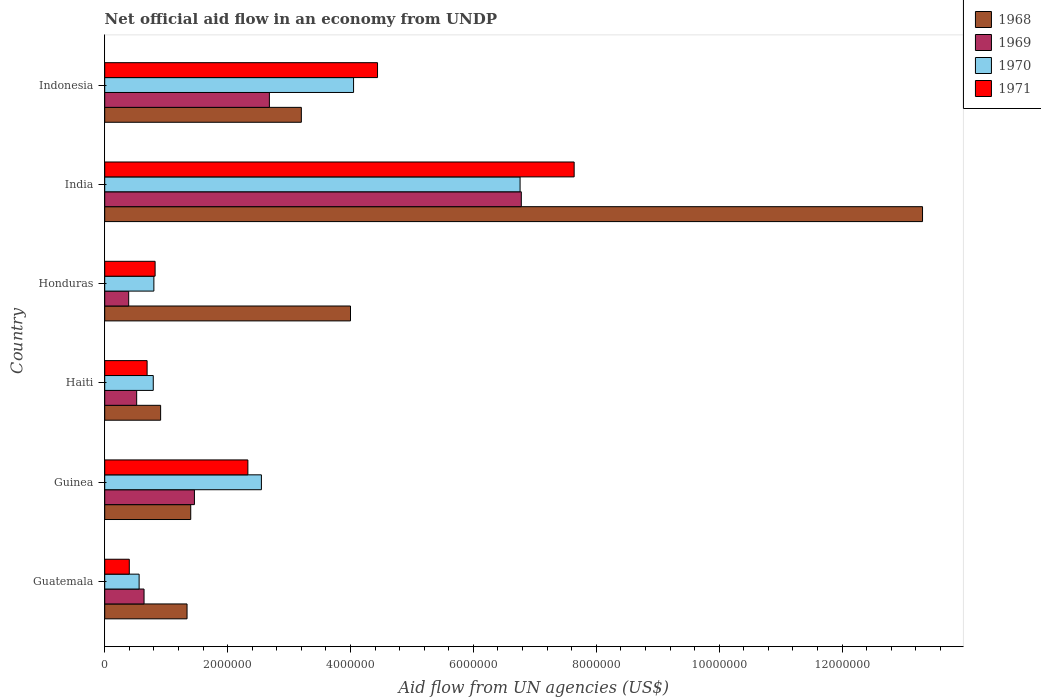Are the number of bars per tick equal to the number of legend labels?
Keep it short and to the point. Yes. Are the number of bars on each tick of the Y-axis equal?
Offer a terse response. Yes. What is the label of the 3rd group of bars from the top?
Offer a terse response. Honduras. What is the net official aid flow in 1968 in Guatemala?
Ensure brevity in your answer.  1.34e+06. Across all countries, what is the maximum net official aid flow in 1968?
Make the answer very short. 1.33e+07. Across all countries, what is the minimum net official aid flow in 1971?
Make the answer very short. 4.00e+05. In which country was the net official aid flow in 1968 maximum?
Provide a short and direct response. India. In which country was the net official aid flow in 1968 minimum?
Offer a terse response. Haiti. What is the total net official aid flow in 1971 in the graph?
Ensure brevity in your answer.  1.63e+07. What is the difference between the net official aid flow in 1969 in Haiti and the net official aid flow in 1970 in Indonesia?
Give a very brief answer. -3.53e+06. What is the average net official aid flow in 1969 per country?
Provide a succinct answer. 2.08e+06. What is the difference between the net official aid flow in 1968 and net official aid flow in 1969 in Guinea?
Offer a very short reply. -6.00e+04. What is the ratio of the net official aid flow in 1968 in Guinea to that in India?
Give a very brief answer. 0.11. What is the difference between the highest and the second highest net official aid flow in 1968?
Provide a succinct answer. 9.31e+06. What is the difference between the highest and the lowest net official aid flow in 1971?
Your answer should be very brief. 7.24e+06. In how many countries, is the net official aid flow in 1970 greater than the average net official aid flow in 1970 taken over all countries?
Your response must be concise. 2. Is the sum of the net official aid flow in 1970 in Guinea and India greater than the maximum net official aid flow in 1968 across all countries?
Give a very brief answer. No. What does the 4th bar from the top in India represents?
Ensure brevity in your answer.  1968. What does the 2nd bar from the bottom in India represents?
Give a very brief answer. 1969. How many bars are there?
Make the answer very short. 24. Are all the bars in the graph horizontal?
Make the answer very short. Yes. How many legend labels are there?
Keep it short and to the point. 4. What is the title of the graph?
Your answer should be very brief. Net official aid flow in an economy from UNDP. What is the label or title of the X-axis?
Offer a terse response. Aid flow from UN agencies (US$). What is the Aid flow from UN agencies (US$) in 1968 in Guatemala?
Your answer should be compact. 1.34e+06. What is the Aid flow from UN agencies (US$) in 1969 in Guatemala?
Ensure brevity in your answer.  6.40e+05. What is the Aid flow from UN agencies (US$) of 1970 in Guatemala?
Provide a short and direct response. 5.60e+05. What is the Aid flow from UN agencies (US$) of 1968 in Guinea?
Provide a short and direct response. 1.40e+06. What is the Aid flow from UN agencies (US$) of 1969 in Guinea?
Offer a terse response. 1.46e+06. What is the Aid flow from UN agencies (US$) of 1970 in Guinea?
Your answer should be compact. 2.55e+06. What is the Aid flow from UN agencies (US$) in 1971 in Guinea?
Provide a succinct answer. 2.33e+06. What is the Aid flow from UN agencies (US$) of 1968 in Haiti?
Provide a succinct answer. 9.10e+05. What is the Aid flow from UN agencies (US$) in 1969 in Haiti?
Your answer should be very brief. 5.20e+05. What is the Aid flow from UN agencies (US$) in 1970 in Haiti?
Keep it short and to the point. 7.90e+05. What is the Aid flow from UN agencies (US$) of 1971 in Haiti?
Ensure brevity in your answer.  6.90e+05. What is the Aid flow from UN agencies (US$) in 1970 in Honduras?
Provide a succinct answer. 8.00e+05. What is the Aid flow from UN agencies (US$) in 1971 in Honduras?
Provide a short and direct response. 8.20e+05. What is the Aid flow from UN agencies (US$) of 1968 in India?
Your response must be concise. 1.33e+07. What is the Aid flow from UN agencies (US$) in 1969 in India?
Provide a short and direct response. 6.78e+06. What is the Aid flow from UN agencies (US$) in 1970 in India?
Give a very brief answer. 6.76e+06. What is the Aid flow from UN agencies (US$) in 1971 in India?
Your answer should be compact. 7.64e+06. What is the Aid flow from UN agencies (US$) of 1968 in Indonesia?
Give a very brief answer. 3.20e+06. What is the Aid flow from UN agencies (US$) in 1969 in Indonesia?
Your answer should be very brief. 2.68e+06. What is the Aid flow from UN agencies (US$) of 1970 in Indonesia?
Your answer should be compact. 4.05e+06. What is the Aid flow from UN agencies (US$) of 1971 in Indonesia?
Your answer should be very brief. 4.44e+06. Across all countries, what is the maximum Aid flow from UN agencies (US$) in 1968?
Provide a short and direct response. 1.33e+07. Across all countries, what is the maximum Aid flow from UN agencies (US$) of 1969?
Provide a short and direct response. 6.78e+06. Across all countries, what is the maximum Aid flow from UN agencies (US$) in 1970?
Ensure brevity in your answer.  6.76e+06. Across all countries, what is the maximum Aid flow from UN agencies (US$) in 1971?
Provide a short and direct response. 7.64e+06. Across all countries, what is the minimum Aid flow from UN agencies (US$) in 1968?
Ensure brevity in your answer.  9.10e+05. Across all countries, what is the minimum Aid flow from UN agencies (US$) of 1970?
Offer a very short reply. 5.60e+05. Across all countries, what is the minimum Aid flow from UN agencies (US$) of 1971?
Ensure brevity in your answer.  4.00e+05. What is the total Aid flow from UN agencies (US$) of 1968 in the graph?
Offer a very short reply. 2.42e+07. What is the total Aid flow from UN agencies (US$) in 1969 in the graph?
Your response must be concise. 1.25e+07. What is the total Aid flow from UN agencies (US$) of 1970 in the graph?
Provide a succinct answer. 1.55e+07. What is the total Aid flow from UN agencies (US$) of 1971 in the graph?
Provide a short and direct response. 1.63e+07. What is the difference between the Aid flow from UN agencies (US$) in 1968 in Guatemala and that in Guinea?
Your response must be concise. -6.00e+04. What is the difference between the Aid flow from UN agencies (US$) in 1969 in Guatemala and that in Guinea?
Offer a very short reply. -8.20e+05. What is the difference between the Aid flow from UN agencies (US$) of 1970 in Guatemala and that in Guinea?
Your answer should be very brief. -1.99e+06. What is the difference between the Aid flow from UN agencies (US$) of 1971 in Guatemala and that in Guinea?
Provide a succinct answer. -1.93e+06. What is the difference between the Aid flow from UN agencies (US$) in 1968 in Guatemala and that in Haiti?
Provide a succinct answer. 4.30e+05. What is the difference between the Aid flow from UN agencies (US$) in 1969 in Guatemala and that in Haiti?
Ensure brevity in your answer.  1.20e+05. What is the difference between the Aid flow from UN agencies (US$) of 1968 in Guatemala and that in Honduras?
Ensure brevity in your answer.  -2.66e+06. What is the difference between the Aid flow from UN agencies (US$) of 1969 in Guatemala and that in Honduras?
Ensure brevity in your answer.  2.50e+05. What is the difference between the Aid flow from UN agencies (US$) in 1970 in Guatemala and that in Honduras?
Your answer should be very brief. -2.40e+05. What is the difference between the Aid flow from UN agencies (US$) of 1971 in Guatemala and that in Honduras?
Keep it short and to the point. -4.20e+05. What is the difference between the Aid flow from UN agencies (US$) in 1968 in Guatemala and that in India?
Your response must be concise. -1.20e+07. What is the difference between the Aid flow from UN agencies (US$) in 1969 in Guatemala and that in India?
Offer a terse response. -6.14e+06. What is the difference between the Aid flow from UN agencies (US$) of 1970 in Guatemala and that in India?
Keep it short and to the point. -6.20e+06. What is the difference between the Aid flow from UN agencies (US$) in 1971 in Guatemala and that in India?
Ensure brevity in your answer.  -7.24e+06. What is the difference between the Aid flow from UN agencies (US$) of 1968 in Guatemala and that in Indonesia?
Ensure brevity in your answer.  -1.86e+06. What is the difference between the Aid flow from UN agencies (US$) in 1969 in Guatemala and that in Indonesia?
Your answer should be compact. -2.04e+06. What is the difference between the Aid flow from UN agencies (US$) of 1970 in Guatemala and that in Indonesia?
Your response must be concise. -3.49e+06. What is the difference between the Aid flow from UN agencies (US$) in 1971 in Guatemala and that in Indonesia?
Keep it short and to the point. -4.04e+06. What is the difference between the Aid flow from UN agencies (US$) of 1968 in Guinea and that in Haiti?
Provide a short and direct response. 4.90e+05. What is the difference between the Aid flow from UN agencies (US$) in 1969 in Guinea and that in Haiti?
Give a very brief answer. 9.40e+05. What is the difference between the Aid flow from UN agencies (US$) in 1970 in Guinea and that in Haiti?
Offer a terse response. 1.76e+06. What is the difference between the Aid flow from UN agencies (US$) in 1971 in Guinea and that in Haiti?
Your response must be concise. 1.64e+06. What is the difference between the Aid flow from UN agencies (US$) of 1968 in Guinea and that in Honduras?
Your response must be concise. -2.60e+06. What is the difference between the Aid flow from UN agencies (US$) in 1969 in Guinea and that in Honduras?
Offer a terse response. 1.07e+06. What is the difference between the Aid flow from UN agencies (US$) in 1970 in Guinea and that in Honduras?
Your answer should be very brief. 1.75e+06. What is the difference between the Aid flow from UN agencies (US$) in 1971 in Guinea and that in Honduras?
Keep it short and to the point. 1.51e+06. What is the difference between the Aid flow from UN agencies (US$) in 1968 in Guinea and that in India?
Offer a very short reply. -1.19e+07. What is the difference between the Aid flow from UN agencies (US$) of 1969 in Guinea and that in India?
Offer a very short reply. -5.32e+06. What is the difference between the Aid flow from UN agencies (US$) in 1970 in Guinea and that in India?
Offer a very short reply. -4.21e+06. What is the difference between the Aid flow from UN agencies (US$) in 1971 in Guinea and that in India?
Provide a short and direct response. -5.31e+06. What is the difference between the Aid flow from UN agencies (US$) of 1968 in Guinea and that in Indonesia?
Offer a very short reply. -1.80e+06. What is the difference between the Aid flow from UN agencies (US$) in 1969 in Guinea and that in Indonesia?
Offer a terse response. -1.22e+06. What is the difference between the Aid flow from UN agencies (US$) of 1970 in Guinea and that in Indonesia?
Your answer should be very brief. -1.50e+06. What is the difference between the Aid flow from UN agencies (US$) of 1971 in Guinea and that in Indonesia?
Provide a succinct answer. -2.11e+06. What is the difference between the Aid flow from UN agencies (US$) in 1968 in Haiti and that in Honduras?
Ensure brevity in your answer.  -3.09e+06. What is the difference between the Aid flow from UN agencies (US$) of 1968 in Haiti and that in India?
Provide a short and direct response. -1.24e+07. What is the difference between the Aid flow from UN agencies (US$) in 1969 in Haiti and that in India?
Provide a short and direct response. -6.26e+06. What is the difference between the Aid flow from UN agencies (US$) of 1970 in Haiti and that in India?
Make the answer very short. -5.97e+06. What is the difference between the Aid flow from UN agencies (US$) in 1971 in Haiti and that in India?
Offer a very short reply. -6.95e+06. What is the difference between the Aid flow from UN agencies (US$) in 1968 in Haiti and that in Indonesia?
Provide a short and direct response. -2.29e+06. What is the difference between the Aid flow from UN agencies (US$) in 1969 in Haiti and that in Indonesia?
Offer a terse response. -2.16e+06. What is the difference between the Aid flow from UN agencies (US$) of 1970 in Haiti and that in Indonesia?
Keep it short and to the point. -3.26e+06. What is the difference between the Aid flow from UN agencies (US$) of 1971 in Haiti and that in Indonesia?
Offer a very short reply. -3.75e+06. What is the difference between the Aid flow from UN agencies (US$) of 1968 in Honduras and that in India?
Provide a short and direct response. -9.31e+06. What is the difference between the Aid flow from UN agencies (US$) of 1969 in Honduras and that in India?
Your answer should be compact. -6.39e+06. What is the difference between the Aid flow from UN agencies (US$) in 1970 in Honduras and that in India?
Offer a terse response. -5.96e+06. What is the difference between the Aid flow from UN agencies (US$) in 1971 in Honduras and that in India?
Keep it short and to the point. -6.82e+06. What is the difference between the Aid flow from UN agencies (US$) of 1969 in Honduras and that in Indonesia?
Provide a succinct answer. -2.29e+06. What is the difference between the Aid flow from UN agencies (US$) of 1970 in Honduras and that in Indonesia?
Ensure brevity in your answer.  -3.25e+06. What is the difference between the Aid flow from UN agencies (US$) in 1971 in Honduras and that in Indonesia?
Give a very brief answer. -3.62e+06. What is the difference between the Aid flow from UN agencies (US$) of 1968 in India and that in Indonesia?
Make the answer very short. 1.01e+07. What is the difference between the Aid flow from UN agencies (US$) in 1969 in India and that in Indonesia?
Give a very brief answer. 4.10e+06. What is the difference between the Aid flow from UN agencies (US$) of 1970 in India and that in Indonesia?
Offer a terse response. 2.71e+06. What is the difference between the Aid flow from UN agencies (US$) in 1971 in India and that in Indonesia?
Provide a short and direct response. 3.20e+06. What is the difference between the Aid flow from UN agencies (US$) in 1968 in Guatemala and the Aid flow from UN agencies (US$) in 1969 in Guinea?
Keep it short and to the point. -1.20e+05. What is the difference between the Aid flow from UN agencies (US$) in 1968 in Guatemala and the Aid flow from UN agencies (US$) in 1970 in Guinea?
Make the answer very short. -1.21e+06. What is the difference between the Aid flow from UN agencies (US$) in 1968 in Guatemala and the Aid flow from UN agencies (US$) in 1971 in Guinea?
Offer a very short reply. -9.90e+05. What is the difference between the Aid flow from UN agencies (US$) of 1969 in Guatemala and the Aid flow from UN agencies (US$) of 1970 in Guinea?
Your answer should be very brief. -1.91e+06. What is the difference between the Aid flow from UN agencies (US$) in 1969 in Guatemala and the Aid flow from UN agencies (US$) in 1971 in Guinea?
Make the answer very short. -1.69e+06. What is the difference between the Aid flow from UN agencies (US$) of 1970 in Guatemala and the Aid flow from UN agencies (US$) of 1971 in Guinea?
Provide a succinct answer. -1.77e+06. What is the difference between the Aid flow from UN agencies (US$) of 1968 in Guatemala and the Aid flow from UN agencies (US$) of 1969 in Haiti?
Your answer should be compact. 8.20e+05. What is the difference between the Aid flow from UN agencies (US$) of 1968 in Guatemala and the Aid flow from UN agencies (US$) of 1970 in Haiti?
Provide a succinct answer. 5.50e+05. What is the difference between the Aid flow from UN agencies (US$) in 1968 in Guatemala and the Aid flow from UN agencies (US$) in 1971 in Haiti?
Offer a very short reply. 6.50e+05. What is the difference between the Aid flow from UN agencies (US$) in 1969 in Guatemala and the Aid flow from UN agencies (US$) in 1970 in Haiti?
Offer a terse response. -1.50e+05. What is the difference between the Aid flow from UN agencies (US$) of 1969 in Guatemala and the Aid flow from UN agencies (US$) of 1971 in Haiti?
Give a very brief answer. -5.00e+04. What is the difference between the Aid flow from UN agencies (US$) of 1970 in Guatemala and the Aid flow from UN agencies (US$) of 1971 in Haiti?
Your answer should be compact. -1.30e+05. What is the difference between the Aid flow from UN agencies (US$) in 1968 in Guatemala and the Aid flow from UN agencies (US$) in 1969 in Honduras?
Your response must be concise. 9.50e+05. What is the difference between the Aid flow from UN agencies (US$) in 1968 in Guatemala and the Aid flow from UN agencies (US$) in 1970 in Honduras?
Your answer should be very brief. 5.40e+05. What is the difference between the Aid flow from UN agencies (US$) in 1968 in Guatemala and the Aid flow from UN agencies (US$) in 1971 in Honduras?
Give a very brief answer. 5.20e+05. What is the difference between the Aid flow from UN agencies (US$) of 1970 in Guatemala and the Aid flow from UN agencies (US$) of 1971 in Honduras?
Offer a terse response. -2.60e+05. What is the difference between the Aid flow from UN agencies (US$) of 1968 in Guatemala and the Aid flow from UN agencies (US$) of 1969 in India?
Give a very brief answer. -5.44e+06. What is the difference between the Aid flow from UN agencies (US$) in 1968 in Guatemala and the Aid flow from UN agencies (US$) in 1970 in India?
Your response must be concise. -5.42e+06. What is the difference between the Aid flow from UN agencies (US$) in 1968 in Guatemala and the Aid flow from UN agencies (US$) in 1971 in India?
Provide a succinct answer. -6.30e+06. What is the difference between the Aid flow from UN agencies (US$) in 1969 in Guatemala and the Aid flow from UN agencies (US$) in 1970 in India?
Keep it short and to the point. -6.12e+06. What is the difference between the Aid flow from UN agencies (US$) of 1969 in Guatemala and the Aid flow from UN agencies (US$) of 1971 in India?
Offer a terse response. -7.00e+06. What is the difference between the Aid flow from UN agencies (US$) of 1970 in Guatemala and the Aid flow from UN agencies (US$) of 1971 in India?
Your answer should be compact. -7.08e+06. What is the difference between the Aid flow from UN agencies (US$) in 1968 in Guatemala and the Aid flow from UN agencies (US$) in 1969 in Indonesia?
Offer a terse response. -1.34e+06. What is the difference between the Aid flow from UN agencies (US$) in 1968 in Guatemala and the Aid flow from UN agencies (US$) in 1970 in Indonesia?
Keep it short and to the point. -2.71e+06. What is the difference between the Aid flow from UN agencies (US$) in 1968 in Guatemala and the Aid flow from UN agencies (US$) in 1971 in Indonesia?
Give a very brief answer. -3.10e+06. What is the difference between the Aid flow from UN agencies (US$) of 1969 in Guatemala and the Aid flow from UN agencies (US$) of 1970 in Indonesia?
Your answer should be very brief. -3.41e+06. What is the difference between the Aid flow from UN agencies (US$) in 1969 in Guatemala and the Aid flow from UN agencies (US$) in 1971 in Indonesia?
Your response must be concise. -3.80e+06. What is the difference between the Aid flow from UN agencies (US$) of 1970 in Guatemala and the Aid flow from UN agencies (US$) of 1971 in Indonesia?
Offer a terse response. -3.88e+06. What is the difference between the Aid flow from UN agencies (US$) of 1968 in Guinea and the Aid flow from UN agencies (US$) of 1969 in Haiti?
Ensure brevity in your answer.  8.80e+05. What is the difference between the Aid flow from UN agencies (US$) in 1968 in Guinea and the Aid flow from UN agencies (US$) in 1970 in Haiti?
Ensure brevity in your answer.  6.10e+05. What is the difference between the Aid flow from UN agencies (US$) in 1968 in Guinea and the Aid flow from UN agencies (US$) in 1971 in Haiti?
Provide a short and direct response. 7.10e+05. What is the difference between the Aid flow from UN agencies (US$) of 1969 in Guinea and the Aid flow from UN agencies (US$) of 1970 in Haiti?
Provide a succinct answer. 6.70e+05. What is the difference between the Aid flow from UN agencies (US$) of 1969 in Guinea and the Aid flow from UN agencies (US$) of 1971 in Haiti?
Your answer should be compact. 7.70e+05. What is the difference between the Aid flow from UN agencies (US$) in 1970 in Guinea and the Aid flow from UN agencies (US$) in 1971 in Haiti?
Offer a terse response. 1.86e+06. What is the difference between the Aid flow from UN agencies (US$) of 1968 in Guinea and the Aid flow from UN agencies (US$) of 1969 in Honduras?
Your answer should be compact. 1.01e+06. What is the difference between the Aid flow from UN agencies (US$) of 1968 in Guinea and the Aid flow from UN agencies (US$) of 1971 in Honduras?
Your answer should be very brief. 5.80e+05. What is the difference between the Aid flow from UN agencies (US$) of 1969 in Guinea and the Aid flow from UN agencies (US$) of 1970 in Honduras?
Offer a terse response. 6.60e+05. What is the difference between the Aid flow from UN agencies (US$) in 1969 in Guinea and the Aid flow from UN agencies (US$) in 1971 in Honduras?
Your response must be concise. 6.40e+05. What is the difference between the Aid flow from UN agencies (US$) in 1970 in Guinea and the Aid flow from UN agencies (US$) in 1971 in Honduras?
Give a very brief answer. 1.73e+06. What is the difference between the Aid flow from UN agencies (US$) of 1968 in Guinea and the Aid flow from UN agencies (US$) of 1969 in India?
Your answer should be very brief. -5.38e+06. What is the difference between the Aid flow from UN agencies (US$) in 1968 in Guinea and the Aid flow from UN agencies (US$) in 1970 in India?
Offer a terse response. -5.36e+06. What is the difference between the Aid flow from UN agencies (US$) of 1968 in Guinea and the Aid flow from UN agencies (US$) of 1971 in India?
Provide a short and direct response. -6.24e+06. What is the difference between the Aid flow from UN agencies (US$) in 1969 in Guinea and the Aid flow from UN agencies (US$) in 1970 in India?
Your answer should be compact. -5.30e+06. What is the difference between the Aid flow from UN agencies (US$) of 1969 in Guinea and the Aid flow from UN agencies (US$) of 1971 in India?
Provide a succinct answer. -6.18e+06. What is the difference between the Aid flow from UN agencies (US$) of 1970 in Guinea and the Aid flow from UN agencies (US$) of 1971 in India?
Provide a short and direct response. -5.09e+06. What is the difference between the Aid flow from UN agencies (US$) in 1968 in Guinea and the Aid flow from UN agencies (US$) in 1969 in Indonesia?
Ensure brevity in your answer.  -1.28e+06. What is the difference between the Aid flow from UN agencies (US$) of 1968 in Guinea and the Aid flow from UN agencies (US$) of 1970 in Indonesia?
Provide a succinct answer. -2.65e+06. What is the difference between the Aid flow from UN agencies (US$) of 1968 in Guinea and the Aid flow from UN agencies (US$) of 1971 in Indonesia?
Provide a short and direct response. -3.04e+06. What is the difference between the Aid flow from UN agencies (US$) of 1969 in Guinea and the Aid flow from UN agencies (US$) of 1970 in Indonesia?
Your answer should be compact. -2.59e+06. What is the difference between the Aid flow from UN agencies (US$) in 1969 in Guinea and the Aid flow from UN agencies (US$) in 1971 in Indonesia?
Make the answer very short. -2.98e+06. What is the difference between the Aid flow from UN agencies (US$) of 1970 in Guinea and the Aid flow from UN agencies (US$) of 1971 in Indonesia?
Keep it short and to the point. -1.89e+06. What is the difference between the Aid flow from UN agencies (US$) in 1968 in Haiti and the Aid flow from UN agencies (US$) in 1969 in Honduras?
Give a very brief answer. 5.20e+05. What is the difference between the Aid flow from UN agencies (US$) of 1969 in Haiti and the Aid flow from UN agencies (US$) of 1970 in Honduras?
Offer a terse response. -2.80e+05. What is the difference between the Aid flow from UN agencies (US$) in 1968 in Haiti and the Aid flow from UN agencies (US$) in 1969 in India?
Your response must be concise. -5.87e+06. What is the difference between the Aid flow from UN agencies (US$) of 1968 in Haiti and the Aid flow from UN agencies (US$) of 1970 in India?
Offer a terse response. -5.85e+06. What is the difference between the Aid flow from UN agencies (US$) in 1968 in Haiti and the Aid flow from UN agencies (US$) in 1971 in India?
Your answer should be very brief. -6.73e+06. What is the difference between the Aid flow from UN agencies (US$) in 1969 in Haiti and the Aid flow from UN agencies (US$) in 1970 in India?
Ensure brevity in your answer.  -6.24e+06. What is the difference between the Aid flow from UN agencies (US$) of 1969 in Haiti and the Aid flow from UN agencies (US$) of 1971 in India?
Give a very brief answer. -7.12e+06. What is the difference between the Aid flow from UN agencies (US$) in 1970 in Haiti and the Aid flow from UN agencies (US$) in 1971 in India?
Ensure brevity in your answer.  -6.85e+06. What is the difference between the Aid flow from UN agencies (US$) in 1968 in Haiti and the Aid flow from UN agencies (US$) in 1969 in Indonesia?
Offer a terse response. -1.77e+06. What is the difference between the Aid flow from UN agencies (US$) of 1968 in Haiti and the Aid flow from UN agencies (US$) of 1970 in Indonesia?
Give a very brief answer. -3.14e+06. What is the difference between the Aid flow from UN agencies (US$) of 1968 in Haiti and the Aid flow from UN agencies (US$) of 1971 in Indonesia?
Your response must be concise. -3.53e+06. What is the difference between the Aid flow from UN agencies (US$) in 1969 in Haiti and the Aid flow from UN agencies (US$) in 1970 in Indonesia?
Provide a succinct answer. -3.53e+06. What is the difference between the Aid flow from UN agencies (US$) of 1969 in Haiti and the Aid flow from UN agencies (US$) of 1971 in Indonesia?
Your answer should be very brief. -3.92e+06. What is the difference between the Aid flow from UN agencies (US$) of 1970 in Haiti and the Aid flow from UN agencies (US$) of 1971 in Indonesia?
Keep it short and to the point. -3.65e+06. What is the difference between the Aid flow from UN agencies (US$) of 1968 in Honduras and the Aid flow from UN agencies (US$) of 1969 in India?
Make the answer very short. -2.78e+06. What is the difference between the Aid flow from UN agencies (US$) in 1968 in Honduras and the Aid flow from UN agencies (US$) in 1970 in India?
Your response must be concise. -2.76e+06. What is the difference between the Aid flow from UN agencies (US$) of 1968 in Honduras and the Aid flow from UN agencies (US$) of 1971 in India?
Provide a short and direct response. -3.64e+06. What is the difference between the Aid flow from UN agencies (US$) of 1969 in Honduras and the Aid flow from UN agencies (US$) of 1970 in India?
Your answer should be very brief. -6.37e+06. What is the difference between the Aid flow from UN agencies (US$) in 1969 in Honduras and the Aid flow from UN agencies (US$) in 1971 in India?
Ensure brevity in your answer.  -7.25e+06. What is the difference between the Aid flow from UN agencies (US$) of 1970 in Honduras and the Aid flow from UN agencies (US$) of 1971 in India?
Your response must be concise. -6.84e+06. What is the difference between the Aid flow from UN agencies (US$) of 1968 in Honduras and the Aid flow from UN agencies (US$) of 1969 in Indonesia?
Keep it short and to the point. 1.32e+06. What is the difference between the Aid flow from UN agencies (US$) in 1968 in Honduras and the Aid flow from UN agencies (US$) in 1970 in Indonesia?
Provide a succinct answer. -5.00e+04. What is the difference between the Aid flow from UN agencies (US$) of 1968 in Honduras and the Aid flow from UN agencies (US$) of 1971 in Indonesia?
Give a very brief answer. -4.40e+05. What is the difference between the Aid flow from UN agencies (US$) of 1969 in Honduras and the Aid flow from UN agencies (US$) of 1970 in Indonesia?
Your response must be concise. -3.66e+06. What is the difference between the Aid flow from UN agencies (US$) of 1969 in Honduras and the Aid flow from UN agencies (US$) of 1971 in Indonesia?
Your answer should be compact. -4.05e+06. What is the difference between the Aid flow from UN agencies (US$) of 1970 in Honduras and the Aid flow from UN agencies (US$) of 1971 in Indonesia?
Your answer should be very brief. -3.64e+06. What is the difference between the Aid flow from UN agencies (US$) in 1968 in India and the Aid flow from UN agencies (US$) in 1969 in Indonesia?
Ensure brevity in your answer.  1.06e+07. What is the difference between the Aid flow from UN agencies (US$) in 1968 in India and the Aid flow from UN agencies (US$) in 1970 in Indonesia?
Your response must be concise. 9.26e+06. What is the difference between the Aid flow from UN agencies (US$) in 1968 in India and the Aid flow from UN agencies (US$) in 1971 in Indonesia?
Give a very brief answer. 8.87e+06. What is the difference between the Aid flow from UN agencies (US$) of 1969 in India and the Aid flow from UN agencies (US$) of 1970 in Indonesia?
Give a very brief answer. 2.73e+06. What is the difference between the Aid flow from UN agencies (US$) in 1969 in India and the Aid flow from UN agencies (US$) in 1971 in Indonesia?
Provide a short and direct response. 2.34e+06. What is the difference between the Aid flow from UN agencies (US$) of 1970 in India and the Aid flow from UN agencies (US$) of 1971 in Indonesia?
Ensure brevity in your answer.  2.32e+06. What is the average Aid flow from UN agencies (US$) in 1968 per country?
Provide a short and direct response. 4.03e+06. What is the average Aid flow from UN agencies (US$) in 1969 per country?
Make the answer very short. 2.08e+06. What is the average Aid flow from UN agencies (US$) in 1970 per country?
Your response must be concise. 2.58e+06. What is the average Aid flow from UN agencies (US$) in 1971 per country?
Make the answer very short. 2.72e+06. What is the difference between the Aid flow from UN agencies (US$) in 1968 and Aid flow from UN agencies (US$) in 1969 in Guatemala?
Make the answer very short. 7.00e+05. What is the difference between the Aid flow from UN agencies (US$) in 1968 and Aid flow from UN agencies (US$) in 1970 in Guatemala?
Your answer should be very brief. 7.80e+05. What is the difference between the Aid flow from UN agencies (US$) of 1968 and Aid flow from UN agencies (US$) of 1971 in Guatemala?
Your answer should be very brief. 9.40e+05. What is the difference between the Aid flow from UN agencies (US$) in 1969 and Aid flow from UN agencies (US$) in 1970 in Guatemala?
Offer a very short reply. 8.00e+04. What is the difference between the Aid flow from UN agencies (US$) in 1969 and Aid flow from UN agencies (US$) in 1971 in Guatemala?
Make the answer very short. 2.40e+05. What is the difference between the Aid flow from UN agencies (US$) of 1970 and Aid flow from UN agencies (US$) of 1971 in Guatemala?
Provide a short and direct response. 1.60e+05. What is the difference between the Aid flow from UN agencies (US$) of 1968 and Aid flow from UN agencies (US$) of 1969 in Guinea?
Provide a short and direct response. -6.00e+04. What is the difference between the Aid flow from UN agencies (US$) of 1968 and Aid flow from UN agencies (US$) of 1970 in Guinea?
Your answer should be very brief. -1.15e+06. What is the difference between the Aid flow from UN agencies (US$) in 1968 and Aid flow from UN agencies (US$) in 1971 in Guinea?
Ensure brevity in your answer.  -9.30e+05. What is the difference between the Aid flow from UN agencies (US$) of 1969 and Aid flow from UN agencies (US$) of 1970 in Guinea?
Give a very brief answer. -1.09e+06. What is the difference between the Aid flow from UN agencies (US$) in 1969 and Aid flow from UN agencies (US$) in 1971 in Guinea?
Your answer should be compact. -8.70e+05. What is the difference between the Aid flow from UN agencies (US$) in 1970 and Aid flow from UN agencies (US$) in 1971 in Guinea?
Your response must be concise. 2.20e+05. What is the difference between the Aid flow from UN agencies (US$) of 1968 and Aid flow from UN agencies (US$) of 1969 in Haiti?
Your answer should be compact. 3.90e+05. What is the difference between the Aid flow from UN agencies (US$) in 1970 and Aid flow from UN agencies (US$) in 1971 in Haiti?
Keep it short and to the point. 1.00e+05. What is the difference between the Aid flow from UN agencies (US$) of 1968 and Aid flow from UN agencies (US$) of 1969 in Honduras?
Ensure brevity in your answer.  3.61e+06. What is the difference between the Aid flow from UN agencies (US$) of 1968 and Aid flow from UN agencies (US$) of 1970 in Honduras?
Your answer should be compact. 3.20e+06. What is the difference between the Aid flow from UN agencies (US$) in 1968 and Aid flow from UN agencies (US$) in 1971 in Honduras?
Make the answer very short. 3.18e+06. What is the difference between the Aid flow from UN agencies (US$) in 1969 and Aid flow from UN agencies (US$) in 1970 in Honduras?
Offer a terse response. -4.10e+05. What is the difference between the Aid flow from UN agencies (US$) of 1969 and Aid flow from UN agencies (US$) of 1971 in Honduras?
Your response must be concise. -4.30e+05. What is the difference between the Aid flow from UN agencies (US$) in 1968 and Aid flow from UN agencies (US$) in 1969 in India?
Give a very brief answer. 6.53e+06. What is the difference between the Aid flow from UN agencies (US$) of 1968 and Aid flow from UN agencies (US$) of 1970 in India?
Make the answer very short. 6.55e+06. What is the difference between the Aid flow from UN agencies (US$) in 1968 and Aid flow from UN agencies (US$) in 1971 in India?
Offer a terse response. 5.67e+06. What is the difference between the Aid flow from UN agencies (US$) of 1969 and Aid flow from UN agencies (US$) of 1971 in India?
Give a very brief answer. -8.60e+05. What is the difference between the Aid flow from UN agencies (US$) of 1970 and Aid flow from UN agencies (US$) of 1971 in India?
Give a very brief answer. -8.80e+05. What is the difference between the Aid flow from UN agencies (US$) in 1968 and Aid flow from UN agencies (US$) in 1969 in Indonesia?
Make the answer very short. 5.20e+05. What is the difference between the Aid flow from UN agencies (US$) of 1968 and Aid flow from UN agencies (US$) of 1970 in Indonesia?
Your response must be concise. -8.50e+05. What is the difference between the Aid flow from UN agencies (US$) in 1968 and Aid flow from UN agencies (US$) in 1971 in Indonesia?
Offer a terse response. -1.24e+06. What is the difference between the Aid flow from UN agencies (US$) in 1969 and Aid flow from UN agencies (US$) in 1970 in Indonesia?
Provide a short and direct response. -1.37e+06. What is the difference between the Aid flow from UN agencies (US$) of 1969 and Aid flow from UN agencies (US$) of 1971 in Indonesia?
Provide a short and direct response. -1.76e+06. What is the difference between the Aid flow from UN agencies (US$) of 1970 and Aid flow from UN agencies (US$) of 1971 in Indonesia?
Keep it short and to the point. -3.90e+05. What is the ratio of the Aid flow from UN agencies (US$) of 1968 in Guatemala to that in Guinea?
Make the answer very short. 0.96. What is the ratio of the Aid flow from UN agencies (US$) in 1969 in Guatemala to that in Guinea?
Offer a very short reply. 0.44. What is the ratio of the Aid flow from UN agencies (US$) in 1970 in Guatemala to that in Guinea?
Provide a short and direct response. 0.22. What is the ratio of the Aid flow from UN agencies (US$) in 1971 in Guatemala to that in Guinea?
Your answer should be very brief. 0.17. What is the ratio of the Aid flow from UN agencies (US$) of 1968 in Guatemala to that in Haiti?
Give a very brief answer. 1.47. What is the ratio of the Aid flow from UN agencies (US$) of 1969 in Guatemala to that in Haiti?
Offer a very short reply. 1.23. What is the ratio of the Aid flow from UN agencies (US$) of 1970 in Guatemala to that in Haiti?
Make the answer very short. 0.71. What is the ratio of the Aid flow from UN agencies (US$) in 1971 in Guatemala to that in Haiti?
Ensure brevity in your answer.  0.58. What is the ratio of the Aid flow from UN agencies (US$) of 1968 in Guatemala to that in Honduras?
Your answer should be very brief. 0.34. What is the ratio of the Aid flow from UN agencies (US$) in 1969 in Guatemala to that in Honduras?
Your answer should be very brief. 1.64. What is the ratio of the Aid flow from UN agencies (US$) of 1971 in Guatemala to that in Honduras?
Ensure brevity in your answer.  0.49. What is the ratio of the Aid flow from UN agencies (US$) in 1968 in Guatemala to that in India?
Your answer should be compact. 0.1. What is the ratio of the Aid flow from UN agencies (US$) in 1969 in Guatemala to that in India?
Offer a terse response. 0.09. What is the ratio of the Aid flow from UN agencies (US$) in 1970 in Guatemala to that in India?
Offer a very short reply. 0.08. What is the ratio of the Aid flow from UN agencies (US$) in 1971 in Guatemala to that in India?
Provide a succinct answer. 0.05. What is the ratio of the Aid flow from UN agencies (US$) in 1968 in Guatemala to that in Indonesia?
Your response must be concise. 0.42. What is the ratio of the Aid flow from UN agencies (US$) of 1969 in Guatemala to that in Indonesia?
Make the answer very short. 0.24. What is the ratio of the Aid flow from UN agencies (US$) in 1970 in Guatemala to that in Indonesia?
Offer a terse response. 0.14. What is the ratio of the Aid flow from UN agencies (US$) of 1971 in Guatemala to that in Indonesia?
Offer a terse response. 0.09. What is the ratio of the Aid flow from UN agencies (US$) in 1968 in Guinea to that in Haiti?
Offer a terse response. 1.54. What is the ratio of the Aid flow from UN agencies (US$) in 1969 in Guinea to that in Haiti?
Your response must be concise. 2.81. What is the ratio of the Aid flow from UN agencies (US$) of 1970 in Guinea to that in Haiti?
Your response must be concise. 3.23. What is the ratio of the Aid flow from UN agencies (US$) in 1971 in Guinea to that in Haiti?
Give a very brief answer. 3.38. What is the ratio of the Aid flow from UN agencies (US$) of 1969 in Guinea to that in Honduras?
Provide a short and direct response. 3.74. What is the ratio of the Aid flow from UN agencies (US$) in 1970 in Guinea to that in Honduras?
Give a very brief answer. 3.19. What is the ratio of the Aid flow from UN agencies (US$) of 1971 in Guinea to that in Honduras?
Give a very brief answer. 2.84. What is the ratio of the Aid flow from UN agencies (US$) of 1968 in Guinea to that in India?
Provide a succinct answer. 0.11. What is the ratio of the Aid flow from UN agencies (US$) in 1969 in Guinea to that in India?
Your answer should be very brief. 0.22. What is the ratio of the Aid flow from UN agencies (US$) of 1970 in Guinea to that in India?
Provide a succinct answer. 0.38. What is the ratio of the Aid flow from UN agencies (US$) in 1971 in Guinea to that in India?
Give a very brief answer. 0.3. What is the ratio of the Aid flow from UN agencies (US$) in 1968 in Guinea to that in Indonesia?
Offer a terse response. 0.44. What is the ratio of the Aid flow from UN agencies (US$) in 1969 in Guinea to that in Indonesia?
Provide a succinct answer. 0.54. What is the ratio of the Aid flow from UN agencies (US$) of 1970 in Guinea to that in Indonesia?
Your answer should be compact. 0.63. What is the ratio of the Aid flow from UN agencies (US$) in 1971 in Guinea to that in Indonesia?
Make the answer very short. 0.52. What is the ratio of the Aid flow from UN agencies (US$) of 1968 in Haiti to that in Honduras?
Keep it short and to the point. 0.23. What is the ratio of the Aid flow from UN agencies (US$) of 1969 in Haiti to that in Honduras?
Your response must be concise. 1.33. What is the ratio of the Aid flow from UN agencies (US$) of 1970 in Haiti to that in Honduras?
Ensure brevity in your answer.  0.99. What is the ratio of the Aid flow from UN agencies (US$) in 1971 in Haiti to that in Honduras?
Offer a terse response. 0.84. What is the ratio of the Aid flow from UN agencies (US$) of 1968 in Haiti to that in India?
Your response must be concise. 0.07. What is the ratio of the Aid flow from UN agencies (US$) of 1969 in Haiti to that in India?
Your answer should be compact. 0.08. What is the ratio of the Aid flow from UN agencies (US$) in 1970 in Haiti to that in India?
Give a very brief answer. 0.12. What is the ratio of the Aid flow from UN agencies (US$) in 1971 in Haiti to that in India?
Provide a succinct answer. 0.09. What is the ratio of the Aid flow from UN agencies (US$) in 1968 in Haiti to that in Indonesia?
Provide a short and direct response. 0.28. What is the ratio of the Aid flow from UN agencies (US$) of 1969 in Haiti to that in Indonesia?
Offer a terse response. 0.19. What is the ratio of the Aid flow from UN agencies (US$) in 1970 in Haiti to that in Indonesia?
Your answer should be compact. 0.2. What is the ratio of the Aid flow from UN agencies (US$) of 1971 in Haiti to that in Indonesia?
Give a very brief answer. 0.16. What is the ratio of the Aid flow from UN agencies (US$) of 1968 in Honduras to that in India?
Provide a succinct answer. 0.3. What is the ratio of the Aid flow from UN agencies (US$) in 1969 in Honduras to that in India?
Your answer should be very brief. 0.06. What is the ratio of the Aid flow from UN agencies (US$) of 1970 in Honduras to that in India?
Keep it short and to the point. 0.12. What is the ratio of the Aid flow from UN agencies (US$) in 1971 in Honduras to that in India?
Provide a short and direct response. 0.11. What is the ratio of the Aid flow from UN agencies (US$) in 1968 in Honduras to that in Indonesia?
Offer a very short reply. 1.25. What is the ratio of the Aid flow from UN agencies (US$) in 1969 in Honduras to that in Indonesia?
Your answer should be compact. 0.15. What is the ratio of the Aid flow from UN agencies (US$) of 1970 in Honduras to that in Indonesia?
Provide a short and direct response. 0.2. What is the ratio of the Aid flow from UN agencies (US$) of 1971 in Honduras to that in Indonesia?
Make the answer very short. 0.18. What is the ratio of the Aid flow from UN agencies (US$) of 1968 in India to that in Indonesia?
Provide a short and direct response. 4.16. What is the ratio of the Aid flow from UN agencies (US$) in 1969 in India to that in Indonesia?
Give a very brief answer. 2.53. What is the ratio of the Aid flow from UN agencies (US$) of 1970 in India to that in Indonesia?
Keep it short and to the point. 1.67. What is the ratio of the Aid flow from UN agencies (US$) of 1971 in India to that in Indonesia?
Provide a short and direct response. 1.72. What is the difference between the highest and the second highest Aid flow from UN agencies (US$) in 1968?
Provide a succinct answer. 9.31e+06. What is the difference between the highest and the second highest Aid flow from UN agencies (US$) of 1969?
Keep it short and to the point. 4.10e+06. What is the difference between the highest and the second highest Aid flow from UN agencies (US$) of 1970?
Offer a very short reply. 2.71e+06. What is the difference between the highest and the second highest Aid flow from UN agencies (US$) in 1971?
Provide a short and direct response. 3.20e+06. What is the difference between the highest and the lowest Aid flow from UN agencies (US$) of 1968?
Make the answer very short. 1.24e+07. What is the difference between the highest and the lowest Aid flow from UN agencies (US$) in 1969?
Ensure brevity in your answer.  6.39e+06. What is the difference between the highest and the lowest Aid flow from UN agencies (US$) in 1970?
Provide a short and direct response. 6.20e+06. What is the difference between the highest and the lowest Aid flow from UN agencies (US$) of 1971?
Keep it short and to the point. 7.24e+06. 